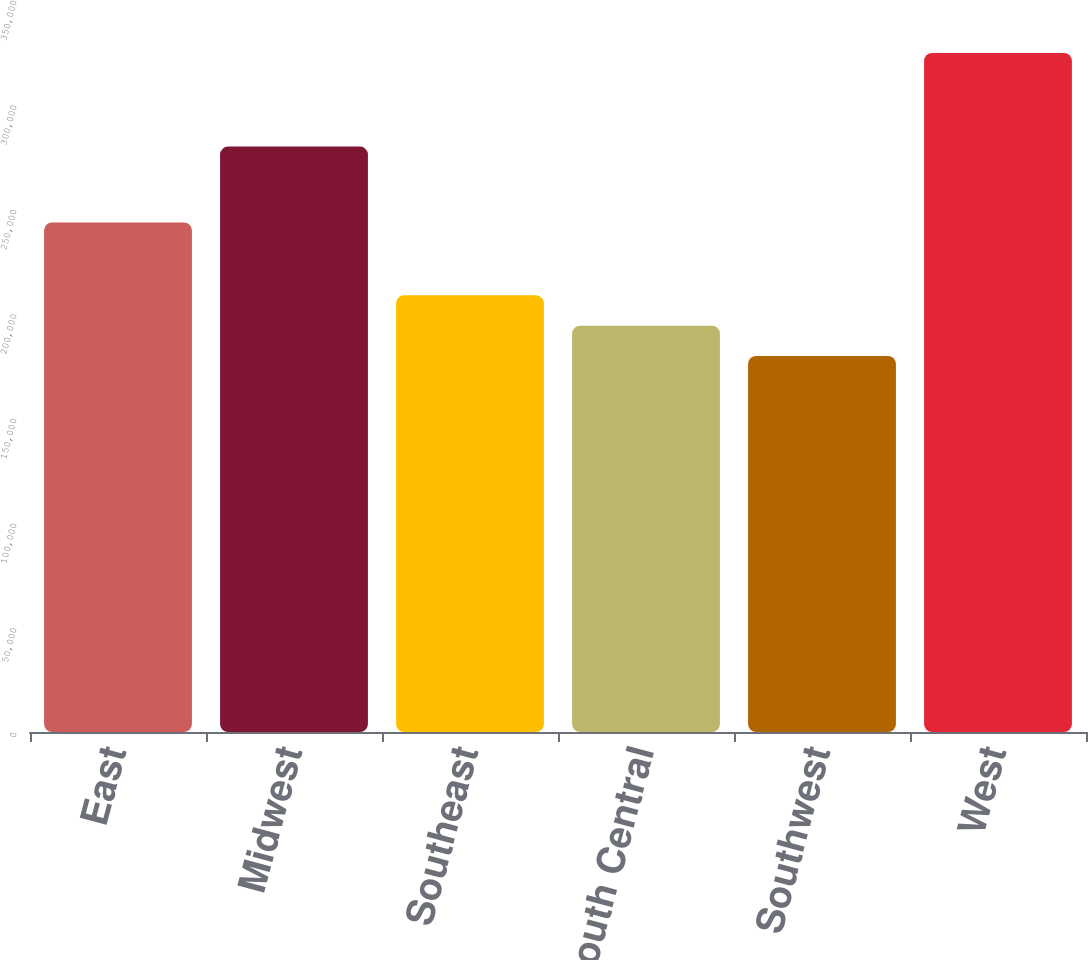Convert chart. <chart><loc_0><loc_0><loc_500><loc_500><bar_chart><fcel>East<fcel>Midwest<fcel>Southeast<fcel>South Central<fcel>Southwest<fcel>West<nl><fcel>243600<fcel>279900<fcel>208780<fcel>194290<fcel>179800<fcel>324700<nl></chart> 